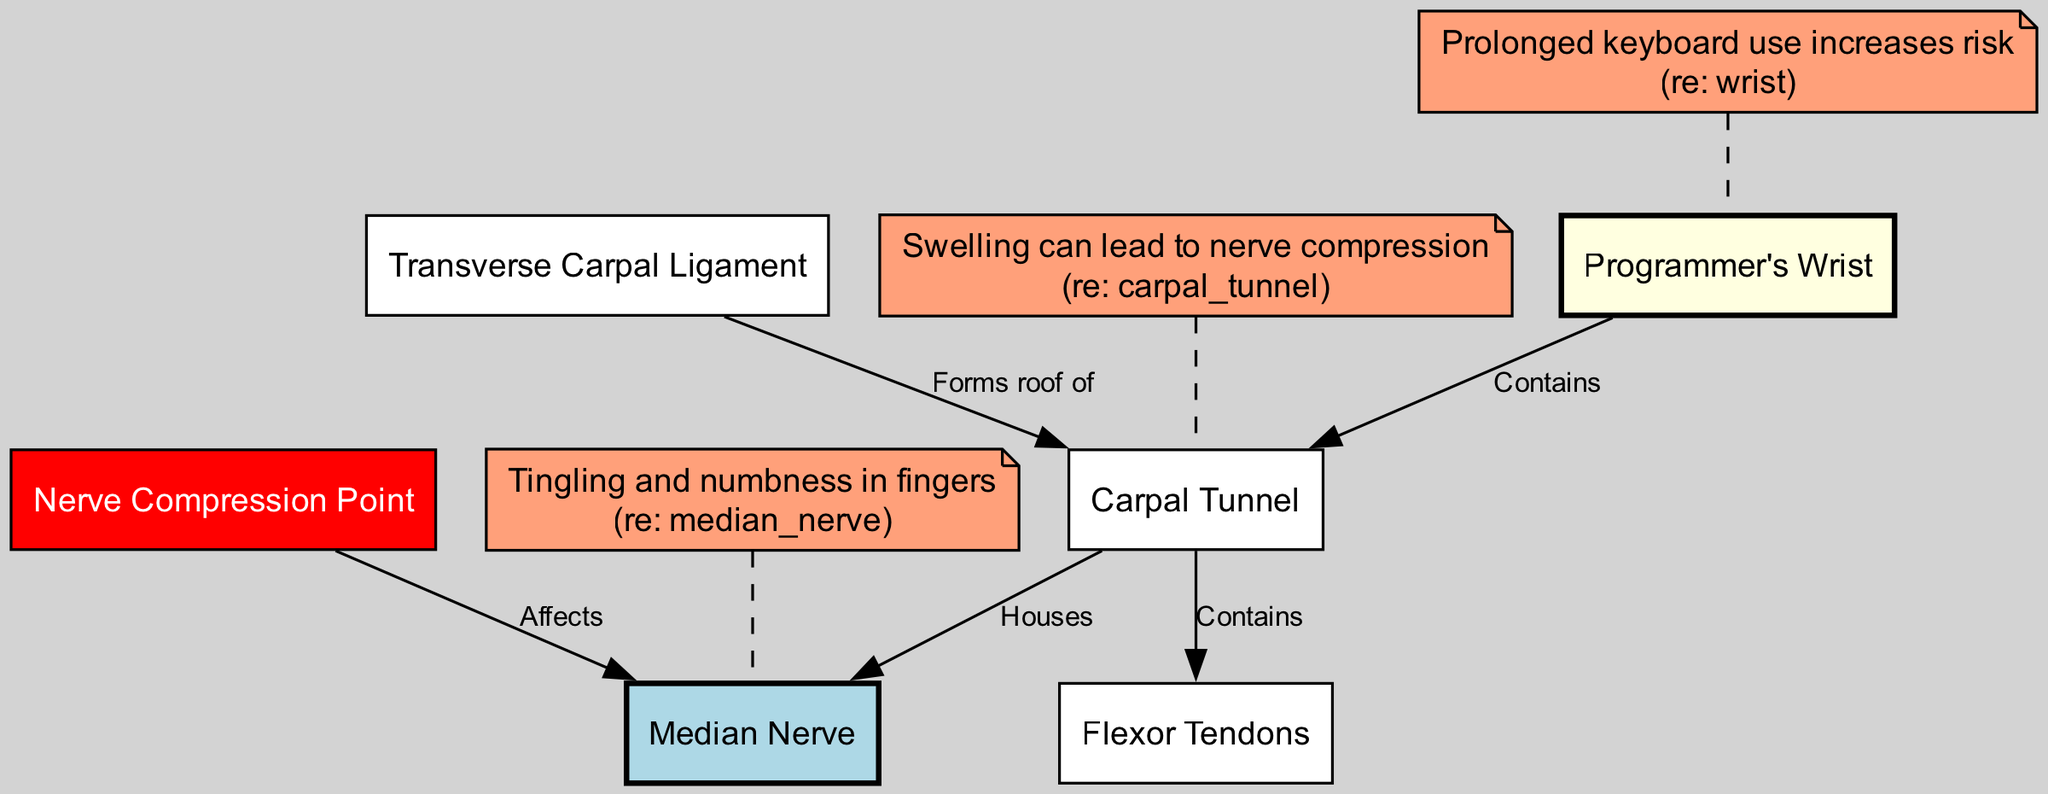What is the primary nerve affected in carpal tunnel syndrome? The diagram specifically identifies the "Median Nerve" as a key structure associated with carpal tunnel syndrome, as indicated by a connection from the "Carpal Tunnel" to the "Median Nerve".
Answer: Median Nerve How many major components are there in this diagram? The diagram displays 6 nodes: the "Programmer's Wrist", "Median Nerve", "Carpal Tunnel", "Flexor Tendons", "Transverse Carpal Ligament", and "Nerve Compression Point", leading to a total count of 6 major components.
Answer: 6 Which structure forms the roof of the carpal tunnel? The diagram indicates the "Transverse Carpal Ligament" specifically connects to the "Carpal Tunnel" with a label indicating it forms the roof of the carpal tunnel.
Answer: Transverse Carpal Ligament What symptom is associated with the median nerve? The diagram presents an annotation pointing to "Tingling and numbness in fingers", highlighting a symptom associated with the "Median Nerve".
Answer: Tingling and numbness in fingers What happens to the median nerve at the compression point? The diagram clearly shows an arrow stating that the "Nerve Compression Point" affects the "Median Nerve", implying there is a detrimental effect on the nerve quality at this location.
Answer: Affects What is indicated as a contributing factor to carpal tunnel syndrome? The diagram includes an annotation that states "Prolonged keyboard use increases risk", suggesting its significance as a contributing factor related to the wrist area.
Answer: Prolonged keyboard use increases risk How do flexor tendons relate to the carpal tunnel? The diagram illustrates that the "Carpal Tunnel" contains the "Flexor Tendons", meaning these tendons are housed within and directly related to the carpal tunnel structure.
Answer: Contains What can lead to nerve compression in the carpal tunnel? The diagram mentions that "Swelling can lead to nerve compression", indicating that swelling is a process that affects the carpal tunnel, contributing to the potential nerve compression.
Answer: Swelling can lead to nerve compression 